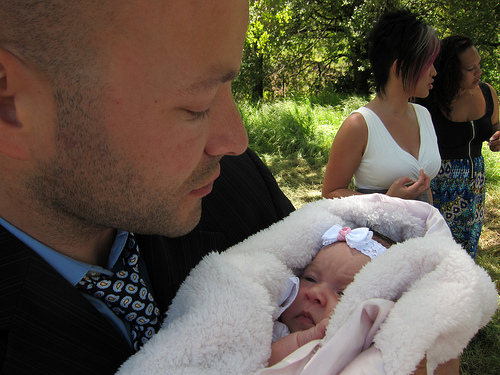<image>
Can you confirm if the man is on the baby? No. The man is not positioned on the baby. They may be near each other, but the man is not supported by or resting on top of the baby. Is the women to the left of the women? Yes. From this viewpoint, the women is positioned to the left side relative to the women. Where is the baby in relation to the woman? Is it under the woman? No. The baby is not positioned under the woman. The vertical relationship between these objects is different. 